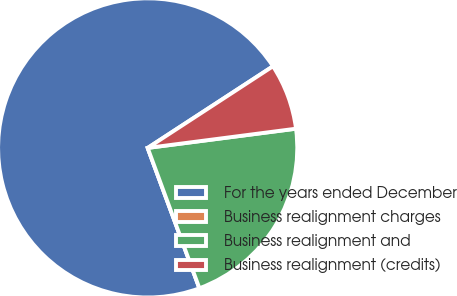Convert chart to OTSL. <chart><loc_0><loc_0><loc_500><loc_500><pie_chart><fcel>For the years ended December<fcel>Business realignment charges<fcel>Business realignment and<fcel>Business realignment (credits)<nl><fcel>71.43%<fcel>0.0%<fcel>21.43%<fcel>7.14%<nl></chart> 